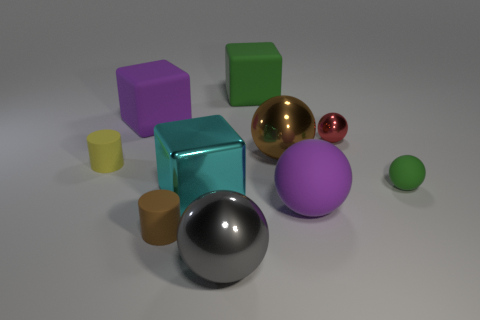Subtract all purple spheres. How many spheres are left? 4 Subtract all large gray spheres. How many spheres are left? 4 Subtract all yellow spheres. Subtract all purple cylinders. How many spheres are left? 5 Subtract all brown rubber objects. Subtract all large purple blocks. How many objects are left? 8 Add 2 spheres. How many spheres are left? 7 Add 1 small green objects. How many small green objects exist? 2 Subtract 1 gray spheres. How many objects are left? 9 Subtract all blocks. How many objects are left? 7 